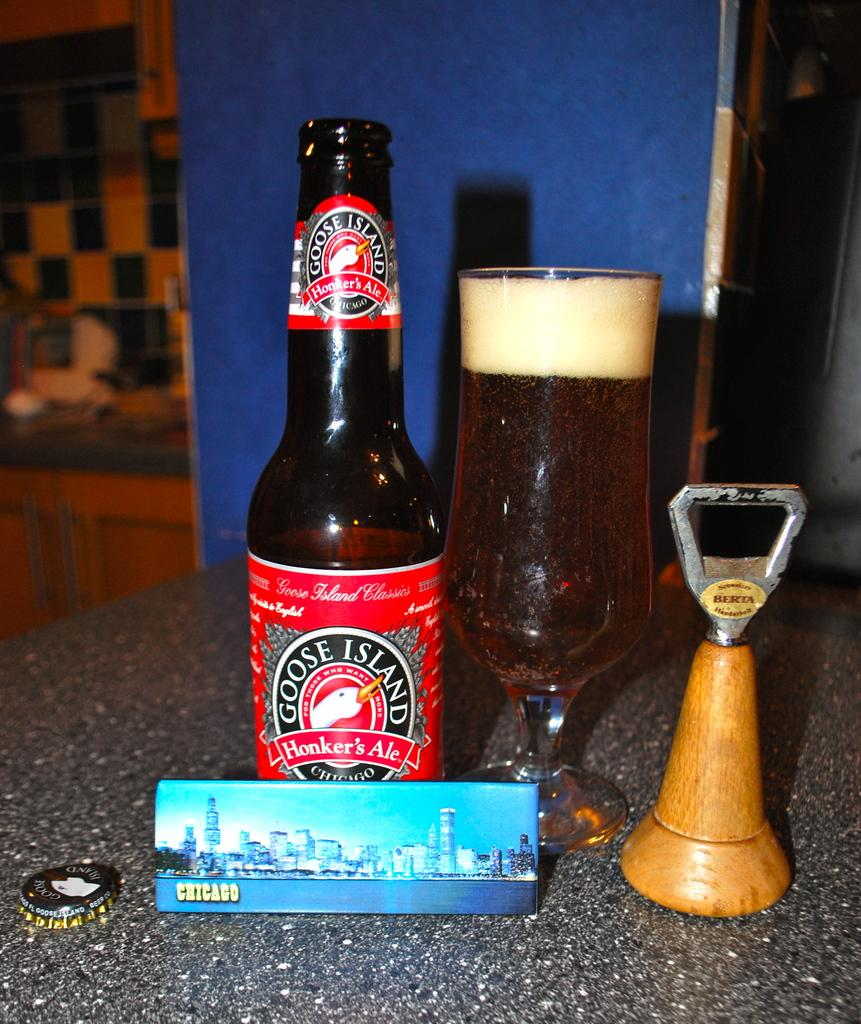<image>
Describe the image concisely. A bottle of Goose Island Honker's Ale poured into a chalice with a picture of Chicago in front of them. 